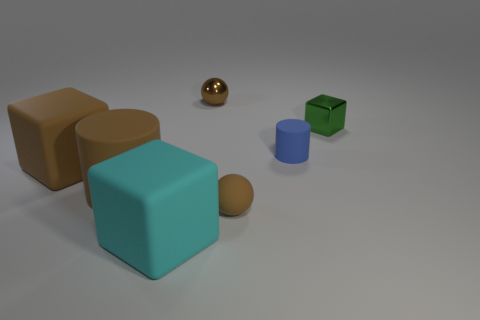There is a small metallic object to the left of the small cube; is its color the same as the large matte cylinder?
Ensure brevity in your answer.  Yes. There is a block that is the same color as the large rubber cylinder; what material is it?
Your answer should be very brief. Rubber. Is there a big cylinder that has the same material as the blue object?
Your answer should be very brief. Yes. There is a brown cylinder; is its size the same as the metal thing that is on the left side of the tiny green metallic thing?
Your answer should be very brief. No. Are there any other tiny spheres of the same color as the rubber sphere?
Provide a short and direct response. Yes. Is the large cylinder made of the same material as the green thing?
Offer a very short reply. No. There is a tiny green object; what number of brown objects are behind it?
Offer a very short reply. 1. There is a tiny object that is both behind the matte ball and to the left of the small blue matte cylinder; what material is it?
Keep it short and to the point. Metal. What number of brown matte objects have the same size as the cyan object?
Keep it short and to the point. 2. There is a small thing behind the block right of the blue matte cylinder; what is its color?
Offer a terse response. Brown. 